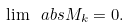Convert formula to latex. <formula><loc_0><loc_0><loc_500><loc_500>\lim \ a b s { M _ { k } } = 0 .</formula> 